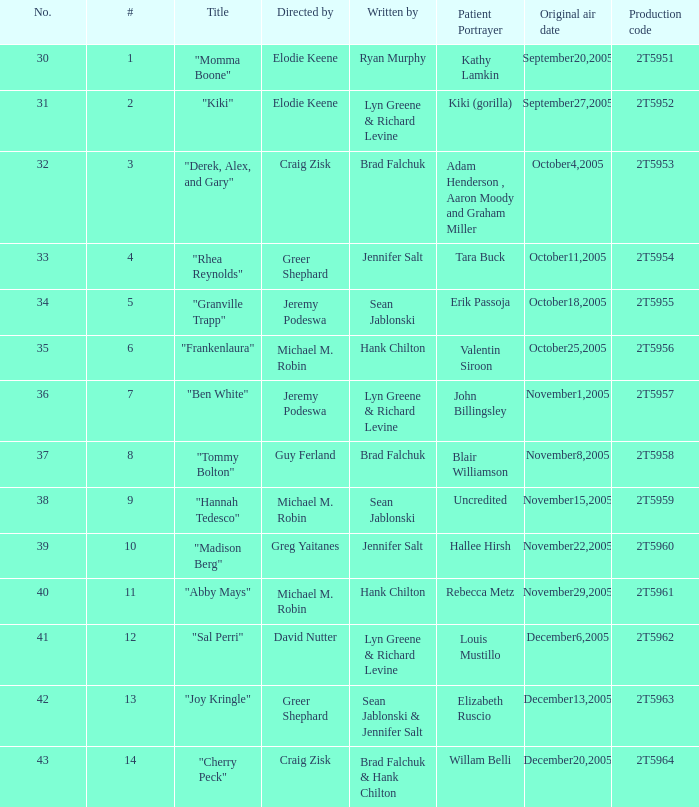Who was the writter for the  episode identified by the production code 2t5954? Jennifer Salt. 